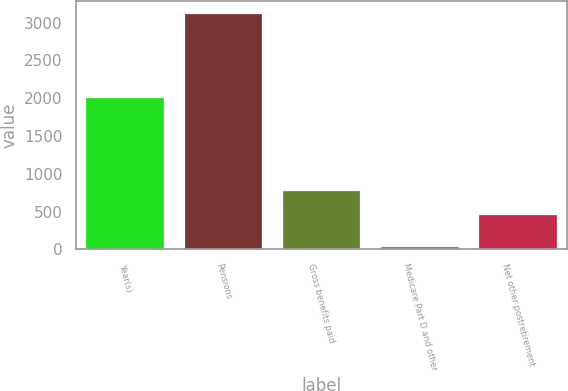Convert chart to OTSL. <chart><loc_0><loc_0><loc_500><loc_500><bar_chart><fcel>Year(s)<fcel>Pensions<fcel>Gross benefits paid<fcel>Medicare Part D and other<fcel>Net other postretirement<nl><fcel>2014<fcel>3132<fcel>780.5<fcel>47<fcel>472<nl></chart> 